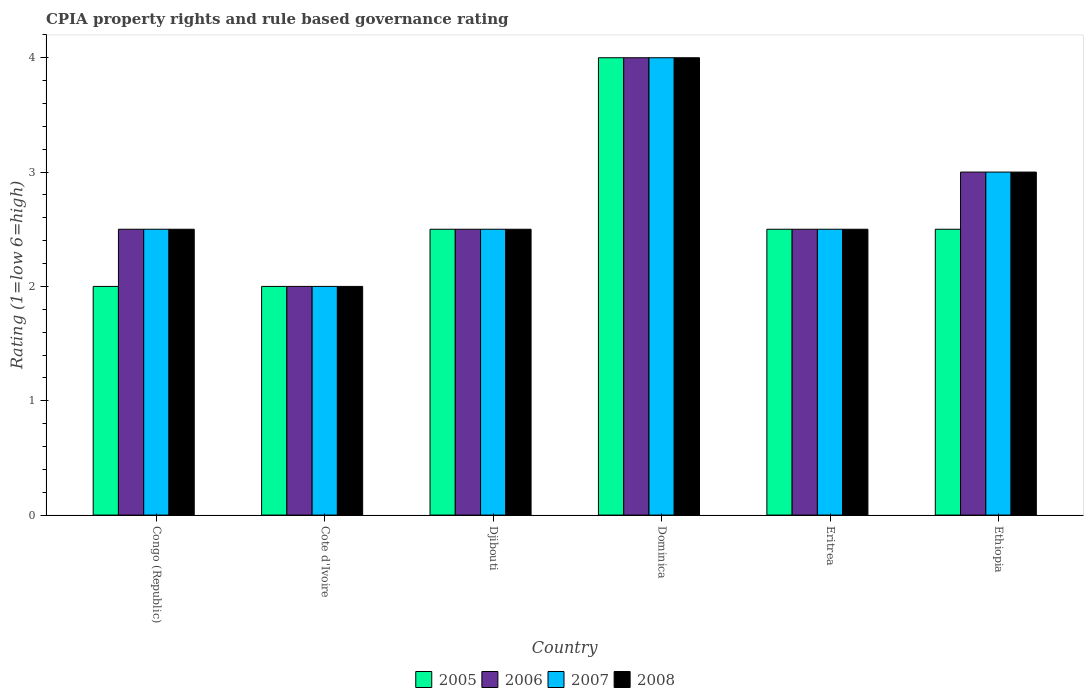How many groups of bars are there?
Keep it short and to the point. 6. Are the number of bars on each tick of the X-axis equal?
Ensure brevity in your answer.  Yes. How many bars are there on the 6th tick from the left?
Ensure brevity in your answer.  4. What is the label of the 2nd group of bars from the left?
Make the answer very short. Cote d'Ivoire. In how many cases, is the number of bars for a given country not equal to the number of legend labels?
Your answer should be compact. 0. What is the CPIA rating in 2008 in Eritrea?
Provide a short and direct response. 2.5. Across all countries, what is the maximum CPIA rating in 2006?
Offer a very short reply. 4. In which country was the CPIA rating in 2008 maximum?
Offer a terse response. Dominica. In which country was the CPIA rating in 2008 minimum?
Provide a short and direct response. Cote d'Ivoire. What is the difference between the CPIA rating in 2005 in Djibouti and that in Eritrea?
Keep it short and to the point. 0. What is the difference between the CPIA rating in 2007 in Eritrea and the CPIA rating in 2006 in Congo (Republic)?
Provide a short and direct response. 0. What is the average CPIA rating in 2008 per country?
Your answer should be compact. 2.75. What is the difference between the CPIA rating of/in 2008 and CPIA rating of/in 2005 in Eritrea?
Offer a terse response. 0. Is the CPIA rating in 2006 in Cote d'Ivoire less than that in Eritrea?
Your answer should be very brief. Yes. Is the difference between the CPIA rating in 2008 in Cote d'Ivoire and Eritrea greater than the difference between the CPIA rating in 2005 in Cote d'Ivoire and Eritrea?
Ensure brevity in your answer.  No. What is the difference between the highest and the second highest CPIA rating in 2008?
Give a very brief answer. -0.5. Is it the case that in every country, the sum of the CPIA rating in 2007 and CPIA rating in 2008 is greater than the CPIA rating in 2006?
Make the answer very short. Yes. How many bars are there?
Offer a terse response. 24. Are all the bars in the graph horizontal?
Provide a succinct answer. No. How many countries are there in the graph?
Provide a succinct answer. 6. What is the difference between two consecutive major ticks on the Y-axis?
Give a very brief answer. 1. Are the values on the major ticks of Y-axis written in scientific E-notation?
Ensure brevity in your answer.  No. Does the graph contain any zero values?
Give a very brief answer. No. What is the title of the graph?
Provide a succinct answer. CPIA property rights and rule based governance rating. What is the label or title of the Y-axis?
Offer a very short reply. Rating (1=low 6=high). What is the Rating (1=low 6=high) in 2006 in Congo (Republic)?
Your answer should be compact. 2.5. What is the Rating (1=low 6=high) in 2007 in Congo (Republic)?
Ensure brevity in your answer.  2.5. What is the Rating (1=low 6=high) in 2007 in Cote d'Ivoire?
Ensure brevity in your answer.  2. What is the Rating (1=low 6=high) of 2008 in Cote d'Ivoire?
Your response must be concise. 2. What is the Rating (1=low 6=high) of 2005 in Djibouti?
Offer a terse response. 2.5. What is the Rating (1=low 6=high) of 2005 in Dominica?
Make the answer very short. 4. What is the Rating (1=low 6=high) in 2006 in Dominica?
Offer a very short reply. 4. What is the Rating (1=low 6=high) in 2007 in Dominica?
Your answer should be compact. 4. What is the Rating (1=low 6=high) in 2008 in Dominica?
Ensure brevity in your answer.  4. What is the Rating (1=low 6=high) in 2007 in Eritrea?
Keep it short and to the point. 2.5. What is the Rating (1=low 6=high) of 2008 in Eritrea?
Your response must be concise. 2.5. What is the Rating (1=low 6=high) of 2005 in Ethiopia?
Your response must be concise. 2.5. Across all countries, what is the maximum Rating (1=low 6=high) of 2005?
Your response must be concise. 4. Across all countries, what is the maximum Rating (1=low 6=high) in 2006?
Offer a very short reply. 4. Across all countries, what is the maximum Rating (1=low 6=high) in 2008?
Make the answer very short. 4. What is the total Rating (1=low 6=high) of 2005 in the graph?
Provide a short and direct response. 15.5. What is the total Rating (1=low 6=high) in 2008 in the graph?
Offer a terse response. 16.5. What is the difference between the Rating (1=low 6=high) in 2007 in Congo (Republic) and that in Djibouti?
Offer a terse response. 0. What is the difference between the Rating (1=low 6=high) in 2005 in Congo (Republic) and that in Dominica?
Ensure brevity in your answer.  -2. What is the difference between the Rating (1=low 6=high) in 2006 in Congo (Republic) and that in Dominica?
Your answer should be very brief. -1.5. What is the difference between the Rating (1=low 6=high) in 2007 in Congo (Republic) and that in Dominica?
Give a very brief answer. -1.5. What is the difference between the Rating (1=low 6=high) of 2006 in Congo (Republic) and that in Eritrea?
Your answer should be compact. 0. What is the difference between the Rating (1=low 6=high) in 2007 in Congo (Republic) and that in Eritrea?
Ensure brevity in your answer.  0. What is the difference between the Rating (1=low 6=high) of 2005 in Congo (Republic) and that in Ethiopia?
Your answer should be compact. -0.5. What is the difference between the Rating (1=low 6=high) of 2007 in Congo (Republic) and that in Ethiopia?
Keep it short and to the point. -0.5. What is the difference between the Rating (1=low 6=high) in 2008 in Congo (Republic) and that in Ethiopia?
Keep it short and to the point. -0.5. What is the difference between the Rating (1=low 6=high) in 2007 in Cote d'Ivoire and that in Djibouti?
Offer a very short reply. -0.5. What is the difference between the Rating (1=low 6=high) in 2005 in Cote d'Ivoire and that in Dominica?
Your answer should be very brief. -2. What is the difference between the Rating (1=low 6=high) in 2007 in Cote d'Ivoire and that in Dominica?
Ensure brevity in your answer.  -2. What is the difference between the Rating (1=low 6=high) of 2008 in Cote d'Ivoire and that in Dominica?
Your answer should be compact. -2. What is the difference between the Rating (1=low 6=high) in 2006 in Cote d'Ivoire and that in Eritrea?
Offer a very short reply. -0.5. What is the difference between the Rating (1=low 6=high) of 2005 in Cote d'Ivoire and that in Ethiopia?
Keep it short and to the point. -0.5. What is the difference between the Rating (1=low 6=high) in 2007 in Cote d'Ivoire and that in Ethiopia?
Your answer should be very brief. -1. What is the difference between the Rating (1=low 6=high) in 2005 in Djibouti and that in Dominica?
Your answer should be compact. -1.5. What is the difference between the Rating (1=low 6=high) in 2006 in Djibouti and that in Dominica?
Keep it short and to the point. -1.5. What is the difference between the Rating (1=low 6=high) in 2007 in Djibouti and that in Dominica?
Provide a short and direct response. -1.5. What is the difference between the Rating (1=low 6=high) in 2008 in Djibouti and that in Dominica?
Offer a terse response. -1.5. What is the difference between the Rating (1=low 6=high) of 2005 in Djibouti and that in Eritrea?
Provide a short and direct response. 0. What is the difference between the Rating (1=low 6=high) in 2007 in Djibouti and that in Eritrea?
Your response must be concise. 0. What is the difference between the Rating (1=low 6=high) of 2008 in Djibouti and that in Eritrea?
Your answer should be compact. 0. What is the difference between the Rating (1=low 6=high) of 2006 in Djibouti and that in Ethiopia?
Keep it short and to the point. -0.5. What is the difference between the Rating (1=low 6=high) in 2005 in Dominica and that in Eritrea?
Ensure brevity in your answer.  1.5. What is the difference between the Rating (1=low 6=high) of 2006 in Dominica and that in Eritrea?
Ensure brevity in your answer.  1.5. What is the difference between the Rating (1=low 6=high) of 2007 in Dominica and that in Eritrea?
Your response must be concise. 1.5. What is the difference between the Rating (1=low 6=high) in 2005 in Dominica and that in Ethiopia?
Offer a very short reply. 1.5. What is the difference between the Rating (1=low 6=high) of 2006 in Dominica and that in Ethiopia?
Offer a terse response. 1. What is the difference between the Rating (1=low 6=high) of 2008 in Dominica and that in Ethiopia?
Provide a short and direct response. 1. What is the difference between the Rating (1=low 6=high) of 2005 in Eritrea and that in Ethiopia?
Offer a very short reply. 0. What is the difference between the Rating (1=low 6=high) of 2006 in Eritrea and that in Ethiopia?
Your answer should be compact. -0.5. What is the difference between the Rating (1=low 6=high) in 2008 in Eritrea and that in Ethiopia?
Provide a short and direct response. -0.5. What is the difference between the Rating (1=low 6=high) in 2006 in Congo (Republic) and the Rating (1=low 6=high) in 2007 in Cote d'Ivoire?
Provide a short and direct response. 0.5. What is the difference between the Rating (1=low 6=high) in 2006 in Congo (Republic) and the Rating (1=low 6=high) in 2008 in Cote d'Ivoire?
Keep it short and to the point. 0.5. What is the difference between the Rating (1=low 6=high) of 2005 in Congo (Republic) and the Rating (1=low 6=high) of 2006 in Djibouti?
Ensure brevity in your answer.  -0.5. What is the difference between the Rating (1=low 6=high) in 2005 in Congo (Republic) and the Rating (1=low 6=high) in 2007 in Djibouti?
Offer a very short reply. -0.5. What is the difference between the Rating (1=low 6=high) in 2006 in Congo (Republic) and the Rating (1=low 6=high) in 2008 in Djibouti?
Offer a terse response. 0. What is the difference between the Rating (1=low 6=high) of 2007 in Congo (Republic) and the Rating (1=low 6=high) of 2008 in Djibouti?
Give a very brief answer. 0. What is the difference between the Rating (1=low 6=high) of 2005 in Congo (Republic) and the Rating (1=low 6=high) of 2007 in Dominica?
Keep it short and to the point. -2. What is the difference between the Rating (1=low 6=high) of 2007 in Congo (Republic) and the Rating (1=low 6=high) of 2008 in Dominica?
Your answer should be compact. -1.5. What is the difference between the Rating (1=low 6=high) in 2006 in Congo (Republic) and the Rating (1=low 6=high) in 2007 in Eritrea?
Your response must be concise. 0. What is the difference between the Rating (1=low 6=high) in 2006 in Congo (Republic) and the Rating (1=low 6=high) in 2008 in Eritrea?
Provide a succinct answer. 0. What is the difference between the Rating (1=low 6=high) in 2005 in Congo (Republic) and the Rating (1=low 6=high) in 2006 in Ethiopia?
Offer a terse response. -1. What is the difference between the Rating (1=low 6=high) in 2005 in Congo (Republic) and the Rating (1=low 6=high) in 2007 in Ethiopia?
Make the answer very short. -1. What is the difference between the Rating (1=low 6=high) in 2005 in Congo (Republic) and the Rating (1=low 6=high) in 2008 in Ethiopia?
Offer a very short reply. -1. What is the difference between the Rating (1=low 6=high) in 2006 in Congo (Republic) and the Rating (1=low 6=high) in 2007 in Ethiopia?
Offer a very short reply. -0.5. What is the difference between the Rating (1=low 6=high) of 2006 in Congo (Republic) and the Rating (1=low 6=high) of 2008 in Ethiopia?
Provide a short and direct response. -0.5. What is the difference between the Rating (1=low 6=high) in 2006 in Cote d'Ivoire and the Rating (1=low 6=high) in 2007 in Djibouti?
Offer a terse response. -0.5. What is the difference between the Rating (1=low 6=high) of 2006 in Cote d'Ivoire and the Rating (1=low 6=high) of 2008 in Djibouti?
Your response must be concise. -0.5. What is the difference between the Rating (1=low 6=high) of 2007 in Cote d'Ivoire and the Rating (1=low 6=high) of 2008 in Djibouti?
Your response must be concise. -0.5. What is the difference between the Rating (1=low 6=high) in 2005 in Cote d'Ivoire and the Rating (1=low 6=high) in 2006 in Dominica?
Your answer should be very brief. -2. What is the difference between the Rating (1=low 6=high) in 2005 in Cote d'Ivoire and the Rating (1=low 6=high) in 2008 in Dominica?
Offer a terse response. -2. What is the difference between the Rating (1=low 6=high) of 2006 in Cote d'Ivoire and the Rating (1=low 6=high) of 2008 in Dominica?
Offer a very short reply. -2. What is the difference between the Rating (1=low 6=high) in 2007 in Cote d'Ivoire and the Rating (1=low 6=high) in 2008 in Dominica?
Offer a very short reply. -2. What is the difference between the Rating (1=low 6=high) of 2006 in Cote d'Ivoire and the Rating (1=low 6=high) of 2007 in Eritrea?
Your response must be concise. -0.5. What is the difference between the Rating (1=low 6=high) in 2005 in Cote d'Ivoire and the Rating (1=low 6=high) in 2007 in Ethiopia?
Offer a terse response. -1. What is the difference between the Rating (1=low 6=high) of 2005 in Cote d'Ivoire and the Rating (1=low 6=high) of 2008 in Ethiopia?
Keep it short and to the point. -1. What is the difference between the Rating (1=low 6=high) of 2006 in Cote d'Ivoire and the Rating (1=low 6=high) of 2007 in Ethiopia?
Provide a succinct answer. -1. What is the difference between the Rating (1=low 6=high) in 2007 in Cote d'Ivoire and the Rating (1=low 6=high) in 2008 in Ethiopia?
Provide a short and direct response. -1. What is the difference between the Rating (1=low 6=high) of 2005 in Djibouti and the Rating (1=low 6=high) of 2006 in Dominica?
Your response must be concise. -1.5. What is the difference between the Rating (1=low 6=high) of 2005 in Djibouti and the Rating (1=low 6=high) of 2007 in Dominica?
Provide a succinct answer. -1.5. What is the difference between the Rating (1=low 6=high) in 2005 in Djibouti and the Rating (1=low 6=high) in 2008 in Dominica?
Your answer should be compact. -1.5. What is the difference between the Rating (1=low 6=high) of 2006 in Djibouti and the Rating (1=low 6=high) of 2007 in Dominica?
Give a very brief answer. -1.5. What is the difference between the Rating (1=low 6=high) of 2006 in Djibouti and the Rating (1=low 6=high) of 2008 in Dominica?
Make the answer very short. -1.5. What is the difference between the Rating (1=low 6=high) of 2005 in Djibouti and the Rating (1=low 6=high) of 2007 in Eritrea?
Provide a succinct answer. 0. What is the difference between the Rating (1=low 6=high) of 2005 in Djibouti and the Rating (1=low 6=high) of 2008 in Eritrea?
Make the answer very short. 0. What is the difference between the Rating (1=low 6=high) in 2006 in Djibouti and the Rating (1=low 6=high) in 2008 in Eritrea?
Keep it short and to the point. 0. What is the difference between the Rating (1=low 6=high) of 2005 in Djibouti and the Rating (1=low 6=high) of 2008 in Ethiopia?
Provide a succinct answer. -0.5. What is the difference between the Rating (1=low 6=high) of 2006 in Djibouti and the Rating (1=low 6=high) of 2007 in Ethiopia?
Provide a succinct answer. -0.5. What is the difference between the Rating (1=low 6=high) in 2006 in Djibouti and the Rating (1=low 6=high) in 2008 in Ethiopia?
Your answer should be compact. -0.5. What is the difference between the Rating (1=low 6=high) in 2007 in Djibouti and the Rating (1=low 6=high) in 2008 in Ethiopia?
Offer a very short reply. -0.5. What is the difference between the Rating (1=low 6=high) in 2005 in Dominica and the Rating (1=low 6=high) in 2006 in Eritrea?
Your answer should be compact. 1.5. What is the difference between the Rating (1=low 6=high) of 2005 in Dominica and the Rating (1=low 6=high) of 2007 in Eritrea?
Offer a terse response. 1.5. What is the difference between the Rating (1=low 6=high) in 2007 in Dominica and the Rating (1=low 6=high) in 2008 in Eritrea?
Your response must be concise. 1.5. What is the difference between the Rating (1=low 6=high) in 2005 in Dominica and the Rating (1=low 6=high) in 2007 in Ethiopia?
Provide a succinct answer. 1. What is the difference between the Rating (1=low 6=high) of 2005 in Dominica and the Rating (1=low 6=high) of 2008 in Ethiopia?
Make the answer very short. 1. What is the difference between the Rating (1=low 6=high) in 2006 in Dominica and the Rating (1=low 6=high) in 2008 in Ethiopia?
Your response must be concise. 1. What is the difference between the Rating (1=low 6=high) in 2007 in Dominica and the Rating (1=low 6=high) in 2008 in Ethiopia?
Give a very brief answer. 1. What is the difference between the Rating (1=low 6=high) of 2005 in Eritrea and the Rating (1=low 6=high) of 2008 in Ethiopia?
Offer a terse response. -0.5. What is the difference between the Rating (1=low 6=high) in 2006 in Eritrea and the Rating (1=low 6=high) in 2007 in Ethiopia?
Your answer should be compact. -0.5. What is the difference between the Rating (1=low 6=high) of 2006 in Eritrea and the Rating (1=low 6=high) of 2008 in Ethiopia?
Your answer should be compact. -0.5. What is the average Rating (1=low 6=high) in 2005 per country?
Ensure brevity in your answer.  2.58. What is the average Rating (1=low 6=high) of 2006 per country?
Keep it short and to the point. 2.75. What is the average Rating (1=low 6=high) of 2007 per country?
Ensure brevity in your answer.  2.75. What is the average Rating (1=low 6=high) in 2008 per country?
Provide a succinct answer. 2.75. What is the difference between the Rating (1=low 6=high) of 2005 and Rating (1=low 6=high) of 2008 in Congo (Republic)?
Provide a succinct answer. -0.5. What is the difference between the Rating (1=low 6=high) of 2006 and Rating (1=low 6=high) of 2007 in Congo (Republic)?
Offer a very short reply. 0. What is the difference between the Rating (1=low 6=high) of 2006 and Rating (1=low 6=high) of 2008 in Congo (Republic)?
Provide a short and direct response. 0. What is the difference between the Rating (1=low 6=high) in 2007 and Rating (1=low 6=high) in 2008 in Congo (Republic)?
Give a very brief answer. 0. What is the difference between the Rating (1=low 6=high) in 2005 and Rating (1=low 6=high) in 2008 in Cote d'Ivoire?
Provide a succinct answer. 0. What is the difference between the Rating (1=low 6=high) of 2006 and Rating (1=low 6=high) of 2008 in Cote d'Ivoire?
Make the answer very short. 0. What is the difference between the Rating (1=low 6=high) in 2005 and Rating (1=low 6=high) in 2006 in Djibouti?
Provide a short and direct response. 0. What is the difference between the Rating (1=low 6=high) of 2005 and Rating (1=low 6=high) of 2007 in Djibouti?
Make the answer very short. 0. What is the difference between the Rating (1=low 6=high) of 2006 and Rating (1=low 6=high) of 2007 in Djibouti?
Ensure brevity in your answer.  0. What is the difference between the Rating (1=low 6=high) in 2006 and Rating (1=low 6=high) in 2008 in Djibouti?
Your answer should be compact. 0. What is the difference between the Rating (1=low 6=high) of 2005 and Rating (1=low 6=high) of 2008 in Dominica?
Offer a terse response. 0. What is the difference between the Rating (1=low 6=high) in 2006 and Rating (1=low 6=high) in 2007 in Dominica?
Provide a short and direct response. 0. What is the difference between the Rating (1=low 6=high) in 2005 and Rating (1=low 6=high) in 2006 in Eritrea?
Offer a terse response. 0. What is the difference between the Rating (1=low 6=high) in 2005 and Rating (1=low 6=high) in 2007 in Eritrea?
Your answer should be very brief. 0. What is the difference between the Rating (1=low 6=high) of 2005 and Rating (1=low 6=high) of 2008 in Eritrea?
Offer a very short reply. 0. What is the difference between the Rating (1=low 6=high) in 2006 and Rating (1=low 6=high) in 2007 in Eritrea?
Ensure brevity in your answer.  0. What is the difference between the Rating (1=low 6=high) of 2006 and Rating (1=low 6=high) of 2008 in Eritrea?
Give a very brief answer. 0. What is the difference between the Rating (1=low 6=high) of 2007 and Rating (1=low 6=high) of 2008 in Eritrea?
Ensure brevity in your answer.  0. What is the difference between the Rating (1=low 6=high) in 2005 and Rating (1=low 6=high) in 2006 in Ethiopia?
Make the answer very short. -0.5. What is the difference between the Rating (1=low 6=high) of 2006 and Rating (1=low 6=high) of 2007 in Ethiopia?
Provide a succinct answer. 0. What is the difference between the Rating (1=low 6=high) in 2007 and Rating (1=low 6=high) in 2008 in Ethiopia?
Your answer should be compact. 0. What is the ratio of the Rating (1=low 6=high) of 2006 in Congo (Republic) to that in Cote d'Ivoire?
Ensure brevity in your answer.  1.25. What is the ratio of the Rating (1=low 6=high) of 2008 in Congo (Republic) to that in Cote d'Ivoire?
Make the answer very short. 1.25. What is the ratio of the Rating (1=low 6=high) of 2008 in Congo (Republic) to that in Djibouti?
Offer a terse response. 1. What is the ratio of the Rating (1=low 6=high) of 2005 in Congo (Republic) to that in Dominica?
Provide a short and direct response. 0.5. What is the ratio of the Rating (1=low 6=high) in 2007 in Congo (Republic) to that in Eritrea?
Provide a succinct answer. 1. What is the ratio of the Rating (1=low 6=high) in 2008 in Congo (Republic) to that in Eritrea?
Your answer should be compact. 1. What is the ratio of the Rating (1=low 6=high) in 2007 in Congo (Republic) to that in Ethiopia?
Your answer should be compact. 0.83. What is the ratio of the Rating (1=low 6=high) of 2008 in Congo (Republic) to that in Ethiopia?
Provide a short and direct response. 0.83. What is the ratio of the Rating (1=low 6=high) in 2005 in Cote d'Ivoire to that in Djibouti?
Keep it short and to the point. 0.8. What is the ratio of the Rating (1=low 6=high) of 2006 in Cote d'Ivoire to that in Djibouti?
Your answer should be very brief. 0.8. What is the ratio of the Rating (1=low 6=high) of 2008 in Cote d'Ivoire to that in Djibouti?
Offer a terse response. 0.8. What is the ratio of the Rating (1=low 6=high) in 2005 in Cote d'Ivoire to that in Dominica?
Keep it short and to the point. 0.5. What is the ratio of the Rating (1=low 6=high) in 2006 in Cote d'Ivoire to that in Dominica?
Give a very brief answer. 0.5. What is the ratio of the Rating (1=low 6=high) of 2007 in Cote d'Ivoire to that in Dominica?
Keep it short and to the point. 0.5. What is the ratio of the Rating (1=low 6=high) of 2008 in Cote d'Ivoire to that in Dominica?
Provide a succinct answer. 0.5. What is the ratio of the Rating (1=low 6=high) in 2005 in Cote d'Ivoire to that in Eritrea?
Your answer should be compact. 0.8. What is the ratio of the Rating (1=low 6=high) in 2007 in Cote d'Ivoire to that in Eritrea?
Offer a very short reply. 0.8. What is the ratio of the Rating (1=low 6=high) in 2006 in Cote d'Ivoire to that in Ethiopia?
Give a very brief answer. 0.67. What is the ratio of the Rating (1=low 6=high) of 2007 in Cote d'Ivoire to that in Ethiopia?
Make the answer very short. 0.67. What is the ratio of the Rating (1=low 6=high) of 2008 in Cote d'Ivoire to that in Ethiopia?
Ensure brevity in your answer.  0.67. What is the ratio of the Rating (1=low 6=high) in 2008 in Djibouti to that in Dominica?
Your answer should be compact. 0.62. What is the ratio of the Rating (1=low 6=high) of 2007 in Djibouti to that in Eritrea?
Ensure brevity in your answer.  1. What is the ratio of the Rating (1=low 6=high) of 2008 in Djibouti to that in Ethiopia?
Give a very brief answer. 0.83. What is the ratio of the Rating (1=low 6=high) in 2005 in Dominica to that in Eritrea?
Your response must be concise. 1.6. What is the ratio of the Rating (1=low 6=high) in 2007 in Dominica to that in Eritrea?
Your answer should be compact. 1.6. What is the ratio of the Rating (1=low 6=high) in 2005 in Dominica to that in Ethiopia?
Offer a terse response. 1.6. What is the ratio of the Rating (1=low 6=high) of 2006 in Dominica to that in Ethiopia?
Give a very brief answer. 1.33. What is the difference between the highest and the second highest Rating (1=low 6=high) of 2005?
Your answer should be very brief. 1.5. What is the difference between the highest and the lowest Rating (1=low 6=high) in 2006?
Give a very brief answer. 2. What is the difference between the highest and the lowest Rating (1=low 6=high) in 2007?
Offer a terse response. 2. What is the difference between the highest and the lowest Rating (1=low 6=high) in 2008?
Provide a short and direct response. 2. 